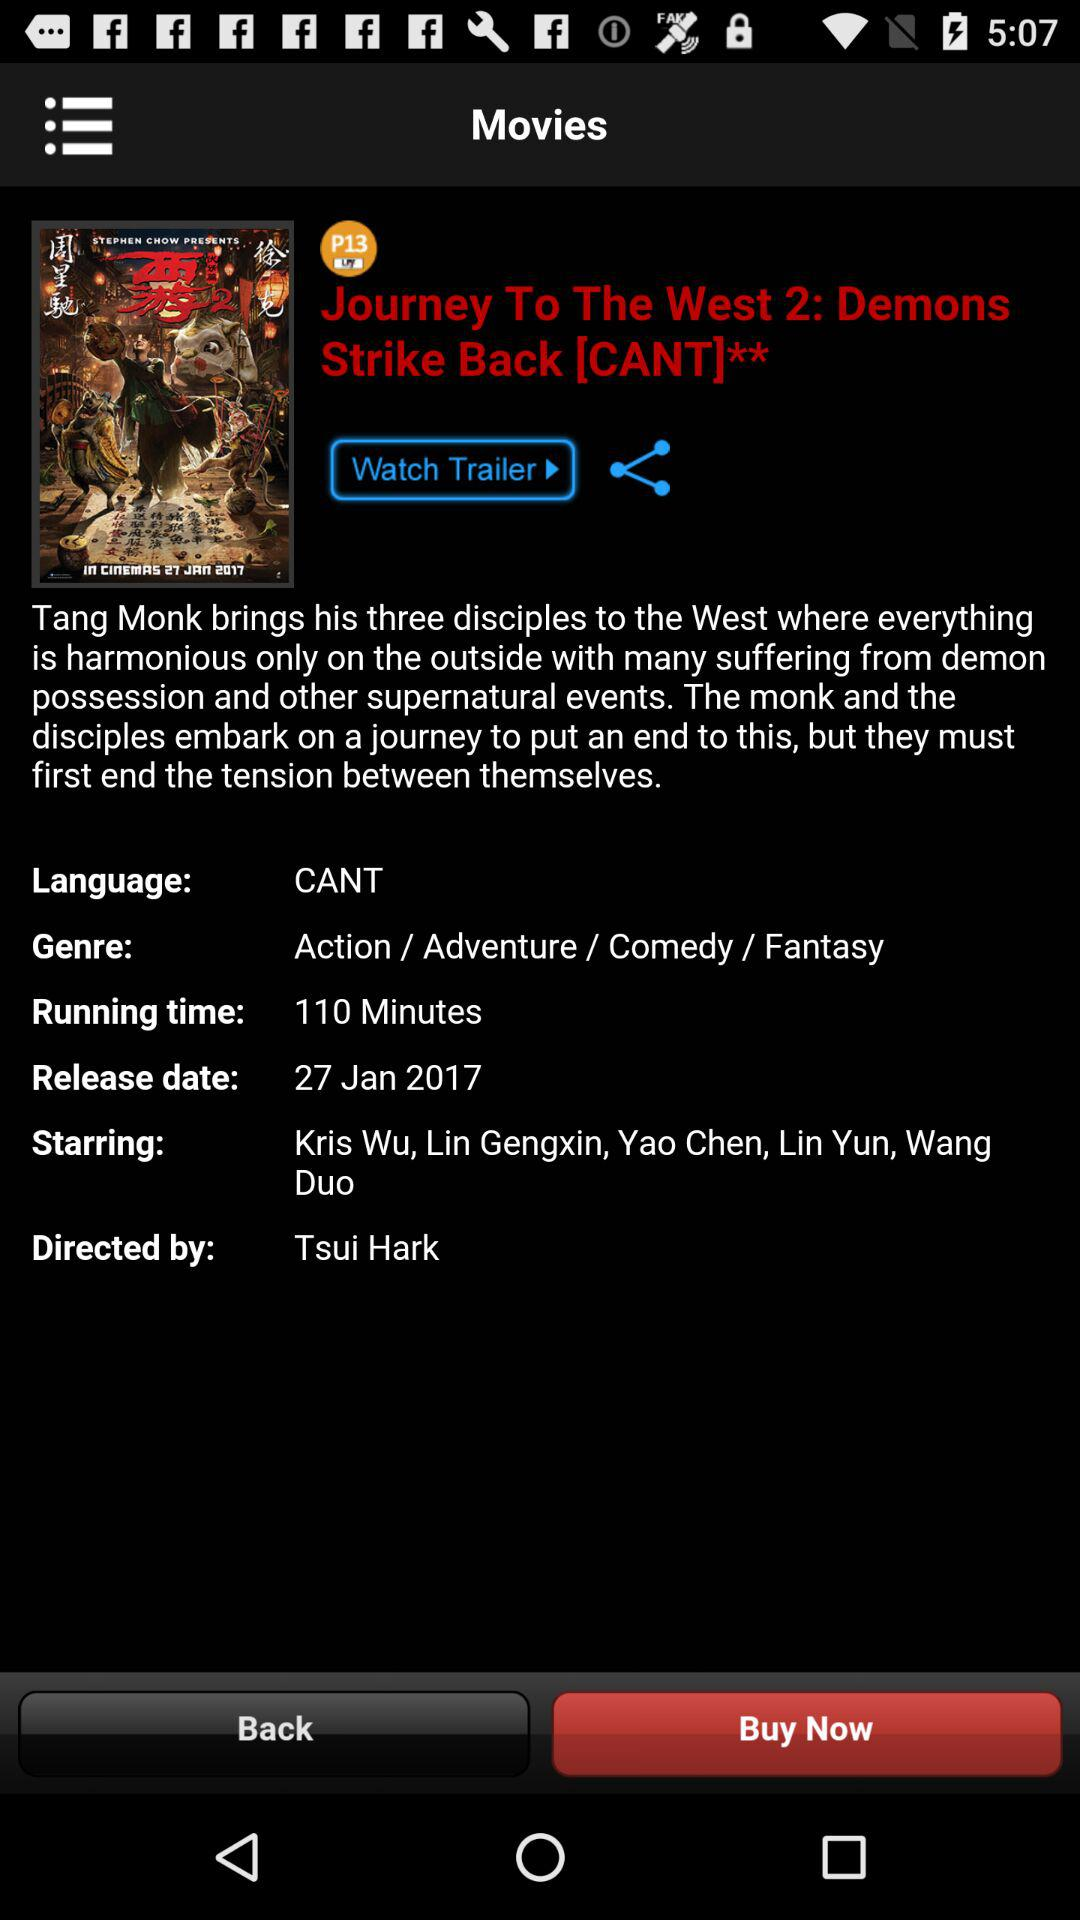What's the genre of the movie? The genres of the movie are action, adventure, comedy and fantasy. 